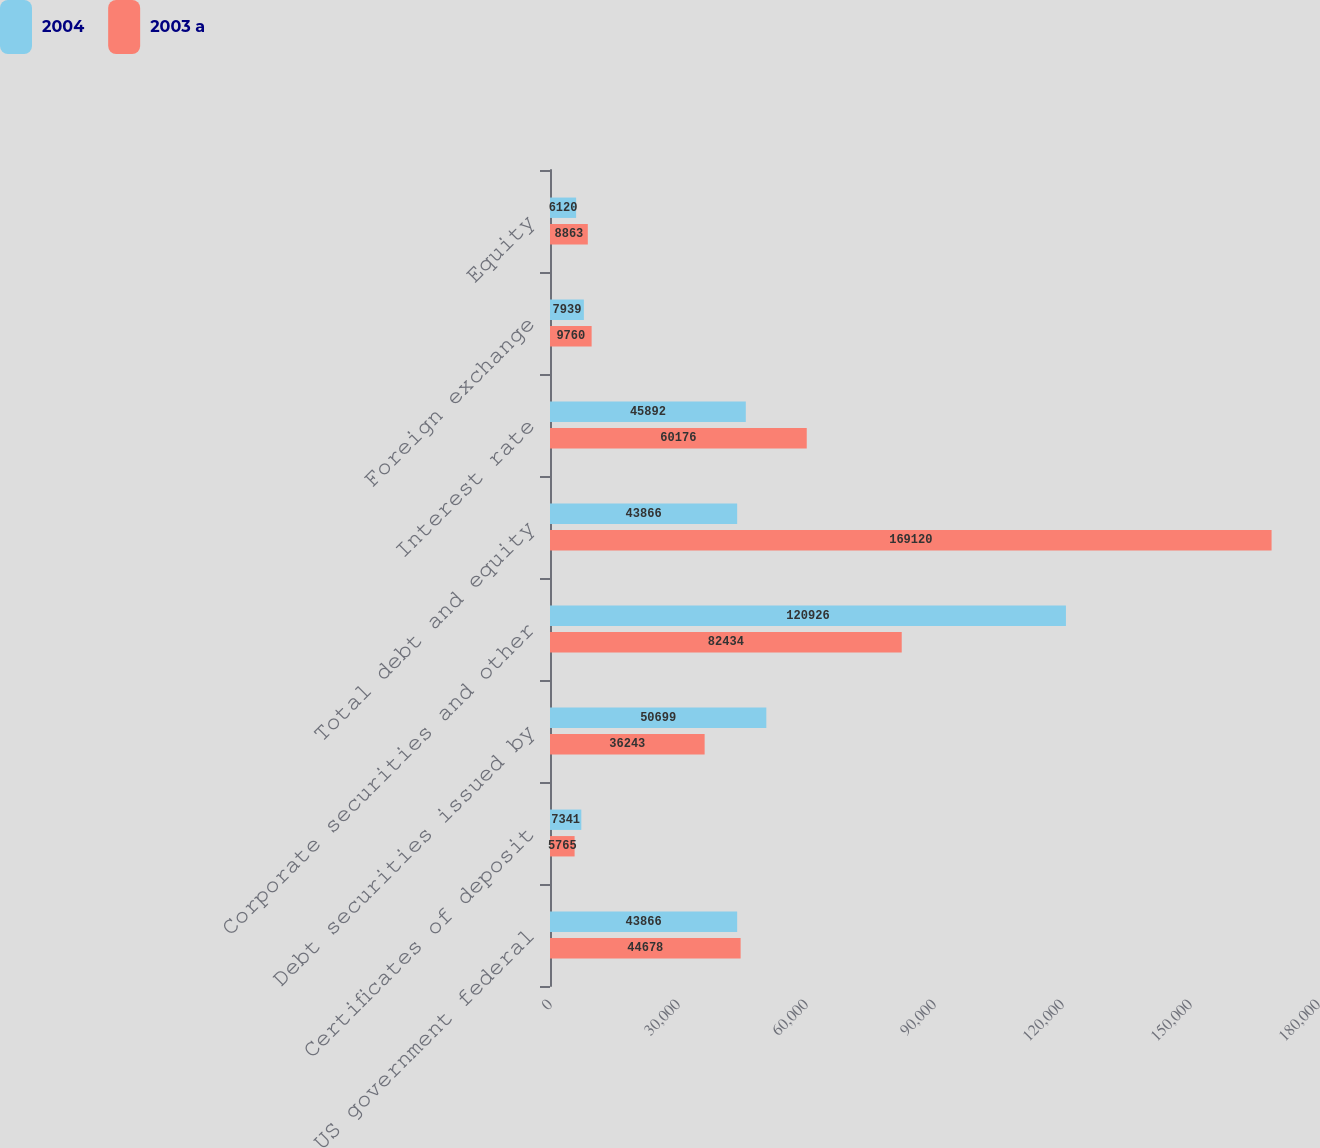Convert chart. <chart><loc_0><loc_0><loc_500><loc_500><stacked_bar_chart><ecel><fcel>US government federal<fcel>Certificates of deposit<fcel>Debt securities issued by<fcel>Corporate securities and other<fcel>Total debt and equity<fcel>Interest rate<fcel>Foreign exchange<fcel>Equity<nl><fcel>2004<fcel>43866<fcel>7341<fcel>50699<fcel>120926<fcel>43866<fcel>45892<fcel>7939<fcel>6120<nl><fcel>2003 a<fcel>44678<fcel>5765<fcel>36243<fcel>82434<fcel>169120<fcel>60176<fcel>9760<fcel>8863<nl></chart> 